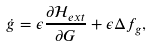<formula> <loc_0><loc_0><loc_500><loc_500>\dot { g } = \epsilon \frac { \partial \mathcal { H } _ { e x t } } { \partial G } + \epsilon \Delta f _ { g } ,</formula> 